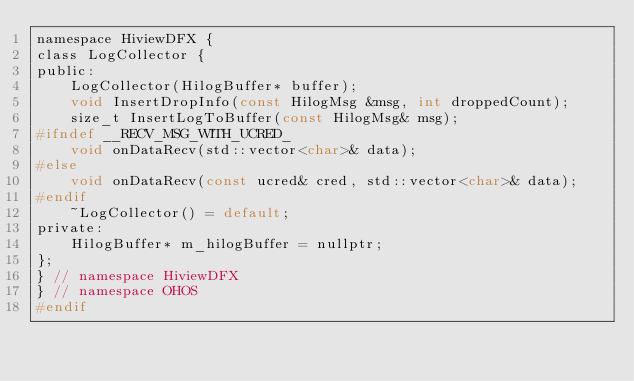<code> <loc_0><loc_0><loc_500><loc_500><_C_>namespace HiviewDFX {
class LogCollector {
public:
    LogCollector(HilogBuffer* buffer);
    void InsertDropInfo(const HilogMsg &msg, int droppedCount);
    size_t InsertLogToBuffer(const HilogMsg& msg);
#ifndef __RECV_MSG_WITH_UCRED_
    void onDataRecv(std::vector<char>& data);
#else
    void onDataRecv(const ucred& cred, std::vector<char>& data);
#endif
    ~LogCollector() = default;
private:
    HilogBuffer* m_hilogBuffer = nullptr;
};
} // namespace HiviewDFX
} // namespace OHOS
#endif</code> 